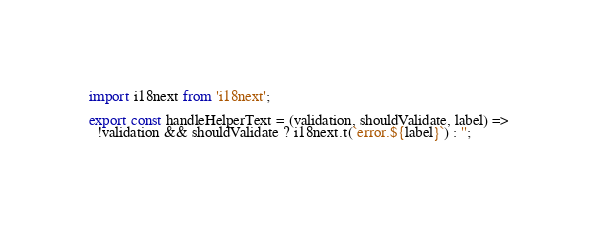Convert code to text. <code><loc_0><loc_0><loc_500><loc_500><_JavaScript_>import i18next from 'i18next';

export const handleHelperText = (validation, shouldValidate, label) =>
  !validation && shouldValidate ? i18next.t(`error.${label}`) : '';
</code> 